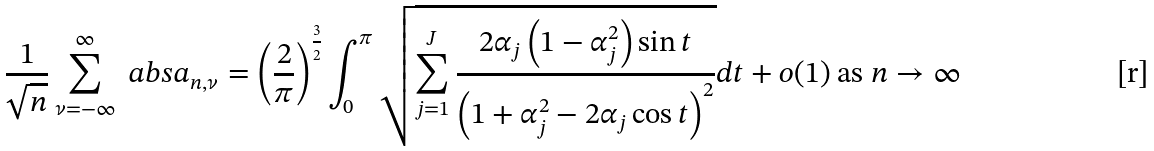Convert formula to latex. <formula><loc_0><loc_0><loc_500><loc_500>\frac { 1 } { \sqrt { n } } \sum _ { \nu = - \infty } ^ { \infty } \ a b s { a _ { n , \nu } } = \left ( \frac { 2 } { \pi } \right ) ^ { \frac { 3 } { 2 } } \int _ { 0 } ^ { \pi } \sqrt { \sum _ { j = 1 } ^ { J } \frac { 2 \alpha _ { j } \left ( 1 - \alpha _ { j } ^ { 2 } \right ) \sin t } { \left ( 1 + \alpha _ { j } ^ { 2 } - 2 \alpha _ { j } \cos t \right ) ^ { 2 } } } d t + o ( 1 ) \text { as $n\rightarrow\infty$}</formula> 